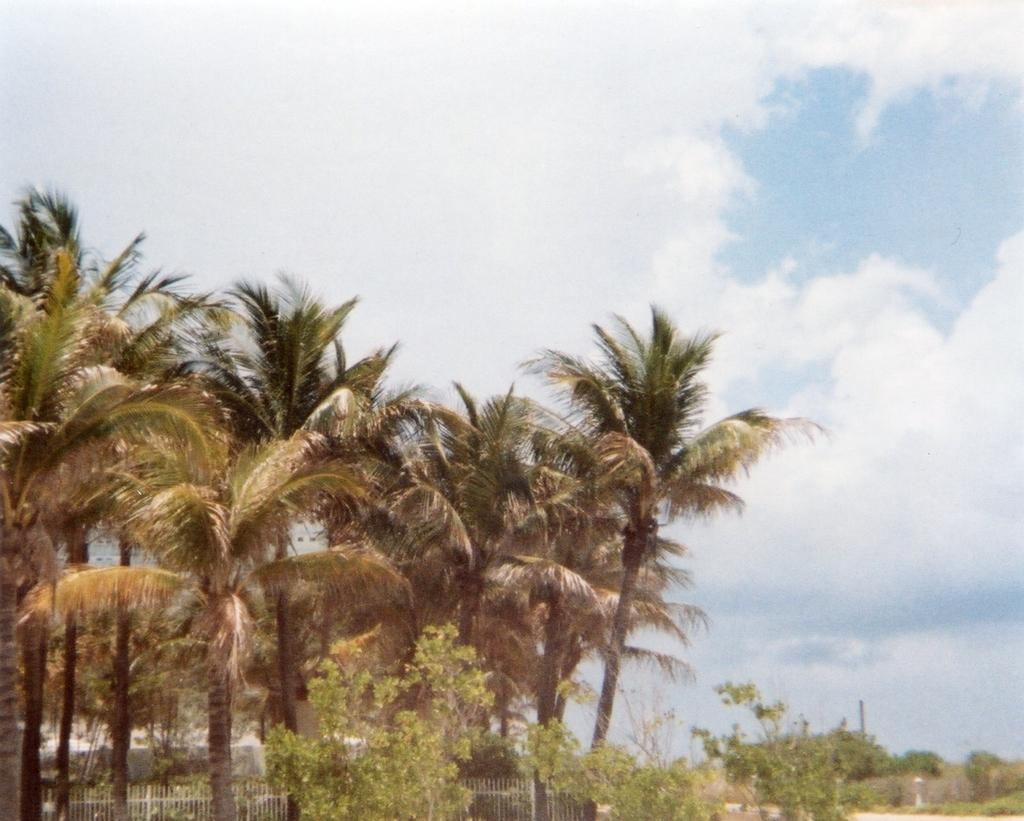What type of trees are on the left side of the image? There are coconut trees on the left side of the image. What is located at the bottom of the image? There is a fence at the bottom of the image. What is visible at the top of the image? The sky is visible at the top of the image. What is present on the land in the image? There are plants on the land. How many borders can be seen in the image? There are no borders visible in the image. 